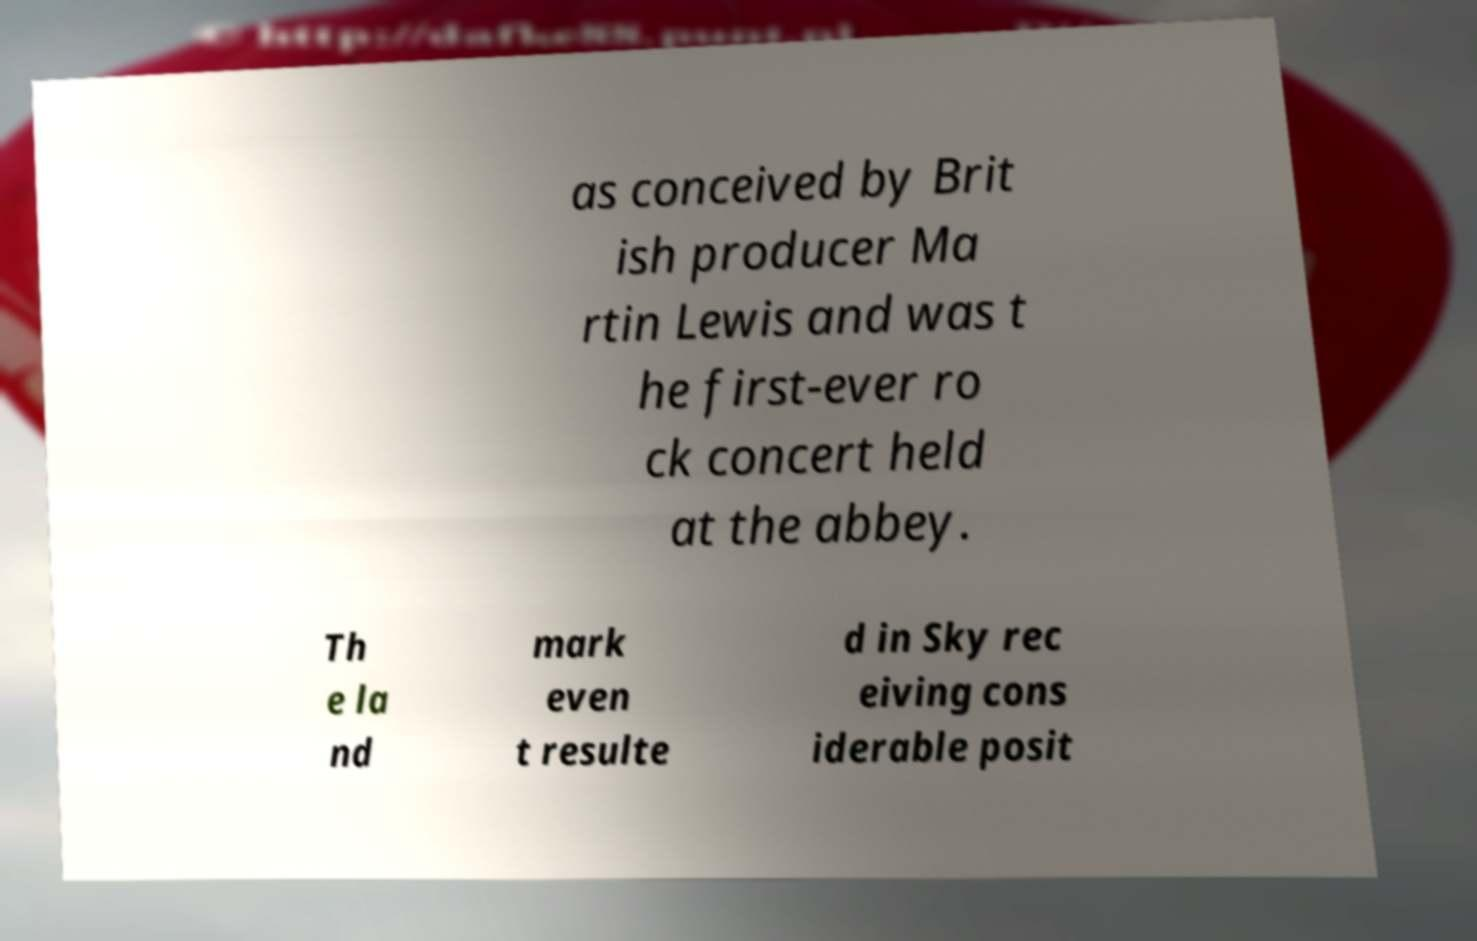Could you extract and type out the text from this image? as conceived by Brit ish producer Ma rtin Lewis and was t he first-ever ro ck concert held at the abbey. Th e la nd mark even t resulte d in Sky rec eiving cons iderable posit 